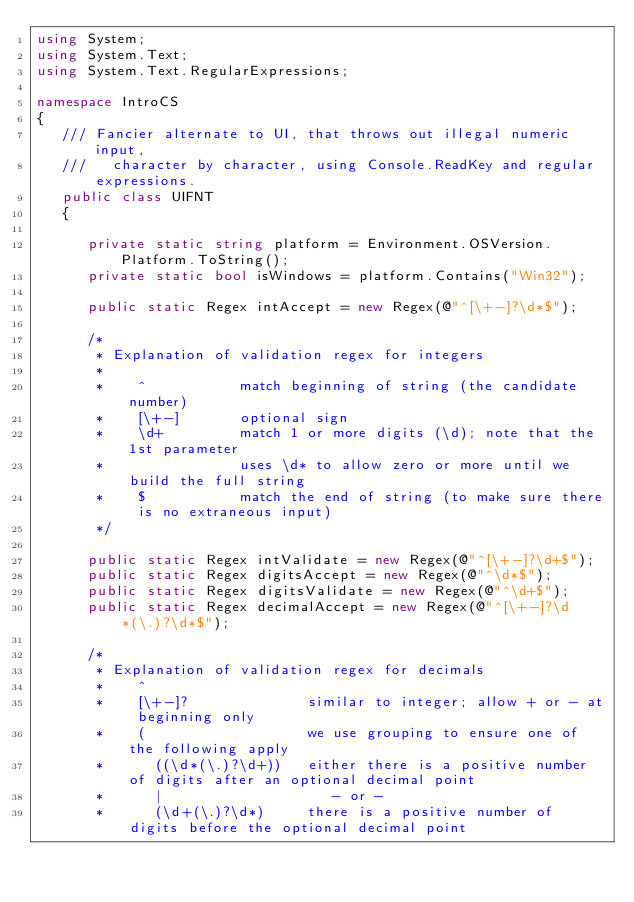<code> <loc_0><loc_0><loc_500><loc_500><_C#_>using System;
using System.Text;
using System.Text.RegularExpressions;

namespace IntroCS
{
   /// Fancier alternate to UI, that throws out illegal numeric input,
   ///   character by character, using Console.ReadKey and regular expressions.
   public class UIFNT
   {

      private static string platform = Environment.OSVersion.Platform.ToString();
      private static bool isWindows = platform.Contains("Win32");

      public static Regex intAccept = new Regex(@"^[\+-]?\d*$");

      /*
       * Explanation of validation regex for integers
       * 
       *    ^           match beginning of string (the candidate number)
       *    [\+-]       optional sign
       *    \d+         match 1 or more digits (\d); note that the 1st parameter 
       *                uses \d* to allow zero or more until we build the full string
       *    $           match the end of string (to make sure there is no extraneous input)
       */

      public static Regex intValidate = new Regex(@"^[\+-]?\d+$");
      public static Regex digitsAccept = new Regex(@"^\d*$");
      public static Regex digitsValidate = new Regex(@"^\d+$");
      public static Regex decimalAccept = new Regex(@"^[\+-]?\d*(\.)?\d*$");

      /*
       * Explanation of validation regex for decimals
       *    ^
       *    [\+-]?              similar to integer; allow + or - at beginning only
       *    (                   we use grouping to ensure one of the following apply
       *      ((\d*(\.)?\d+))   either there is a positive number of digits after an optional decimal point
       *      |                    - or -
       *      (\d+(\.)?\d*)     there is a positive number of digits before the optional decimal point</code> 